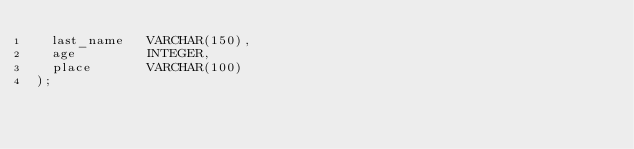Convert code to text. <code><loc_0><loc_0><loc_500><loc_500><_SQL_>  last_name   VARCHAR(150),
  age         INTEGER,
  place       VARCHAR(100)
);</code> 